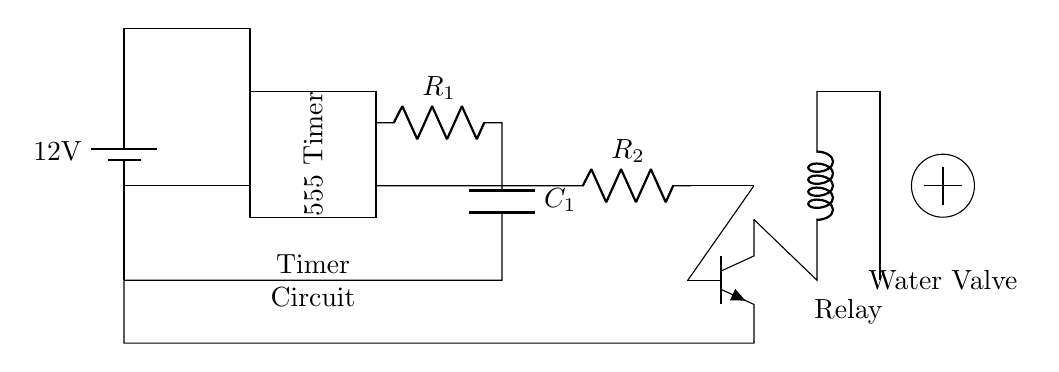What is the voltage of this circuit? The voltage is 12 volts, which is the potential difference provided by the battery in the circuit diagram.
Answer: 12 volts What component is represented by the rectangle labeled "555 Timer"? The rectangle labeled "555 Timer" represents an integrated circuit (IC) that can be configured for timer applications, such as producing a timing interval for the watering system.
Answer: 555 Timer What is the function of the relay in this circuit? The relay acts as a switch that controls the water valve in response to the output signal from the timer circuit, allowing for automated operation of the watering system.
Answer: Switch What does the capacitor labeled C1 do? The capacitor C1 is used to store electrical energy and helps determine the timing interval of the 555 Timer circuit by charging and discharging, influencing how long the water valve remains open.
Answer: Timing How does the transistor function in this circuit? The transistor amplifies the current from the output of the 555 Timer to operate the relay, allowing the low-power control signal to control the higher power needed to actuate the water valve.
Answer: Amplifier What is the purpose of the water valve symbol in this diagram? The water valve symbol indicates the component that controls the flow of water to the garden, which is opened or closed based on the output from the relay, thus automating the watering process.
Answer: Water flow control 